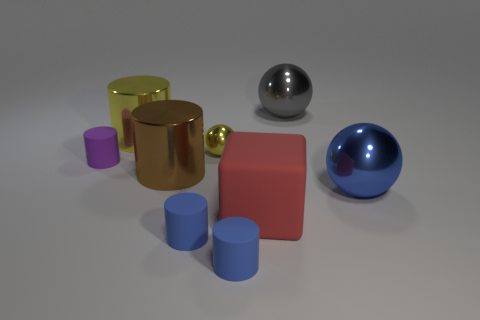Subtract all gray balls. How many balls are left? 2 Subtract all large metallic spheres. How many spheres are left? 1 Add 8 small yellow shiny balls. How many small yellow shiny balls exist? 9 Add 1 brown shiny objects. How many objects exist? 10 Subtract 0 red balls. How many objects are left? 9 Subtract all cylinders. How many objects are left? 4 Subtract 1 blocks. How many blocks are left? 0 Subtract all gray cubes. Subtract all gray cylinders. How many cubes are left? 1 Subtract all blue blocks. How many yellow cylinders are left? 1 Subtract all rubber cylinders. Subtract all small purple rubber things. How many objects are left? 5 